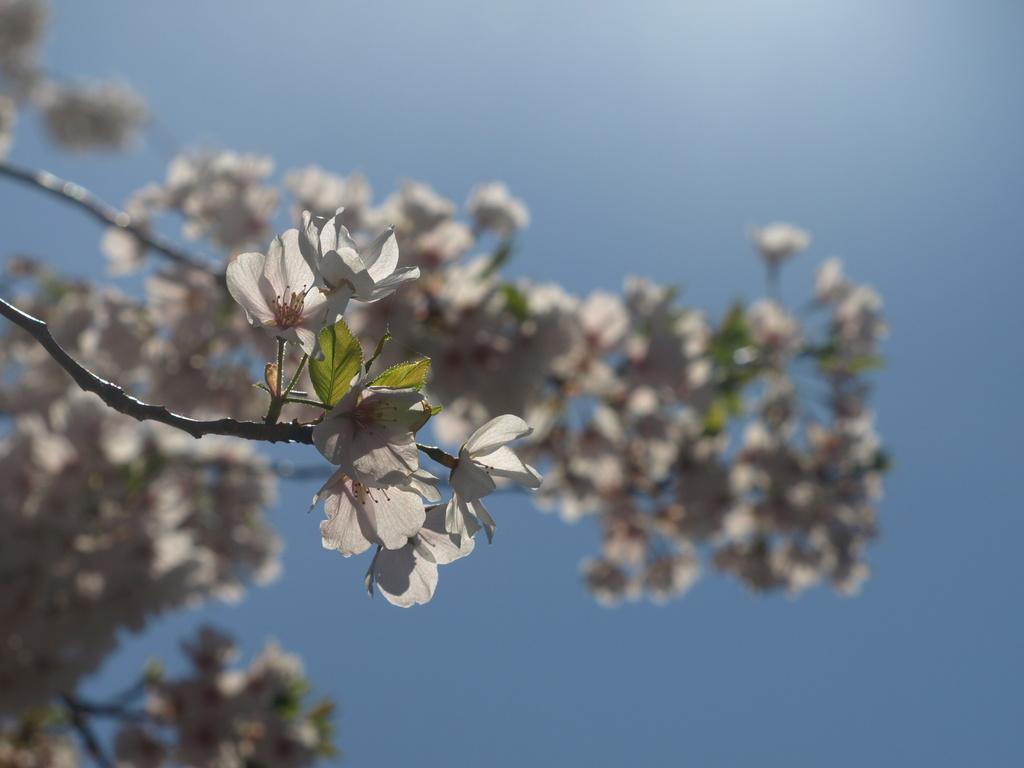In one or two sentences, can you explain what this image depicts? In this picture there is a flower plant in the front. Behind there is a blur background. 